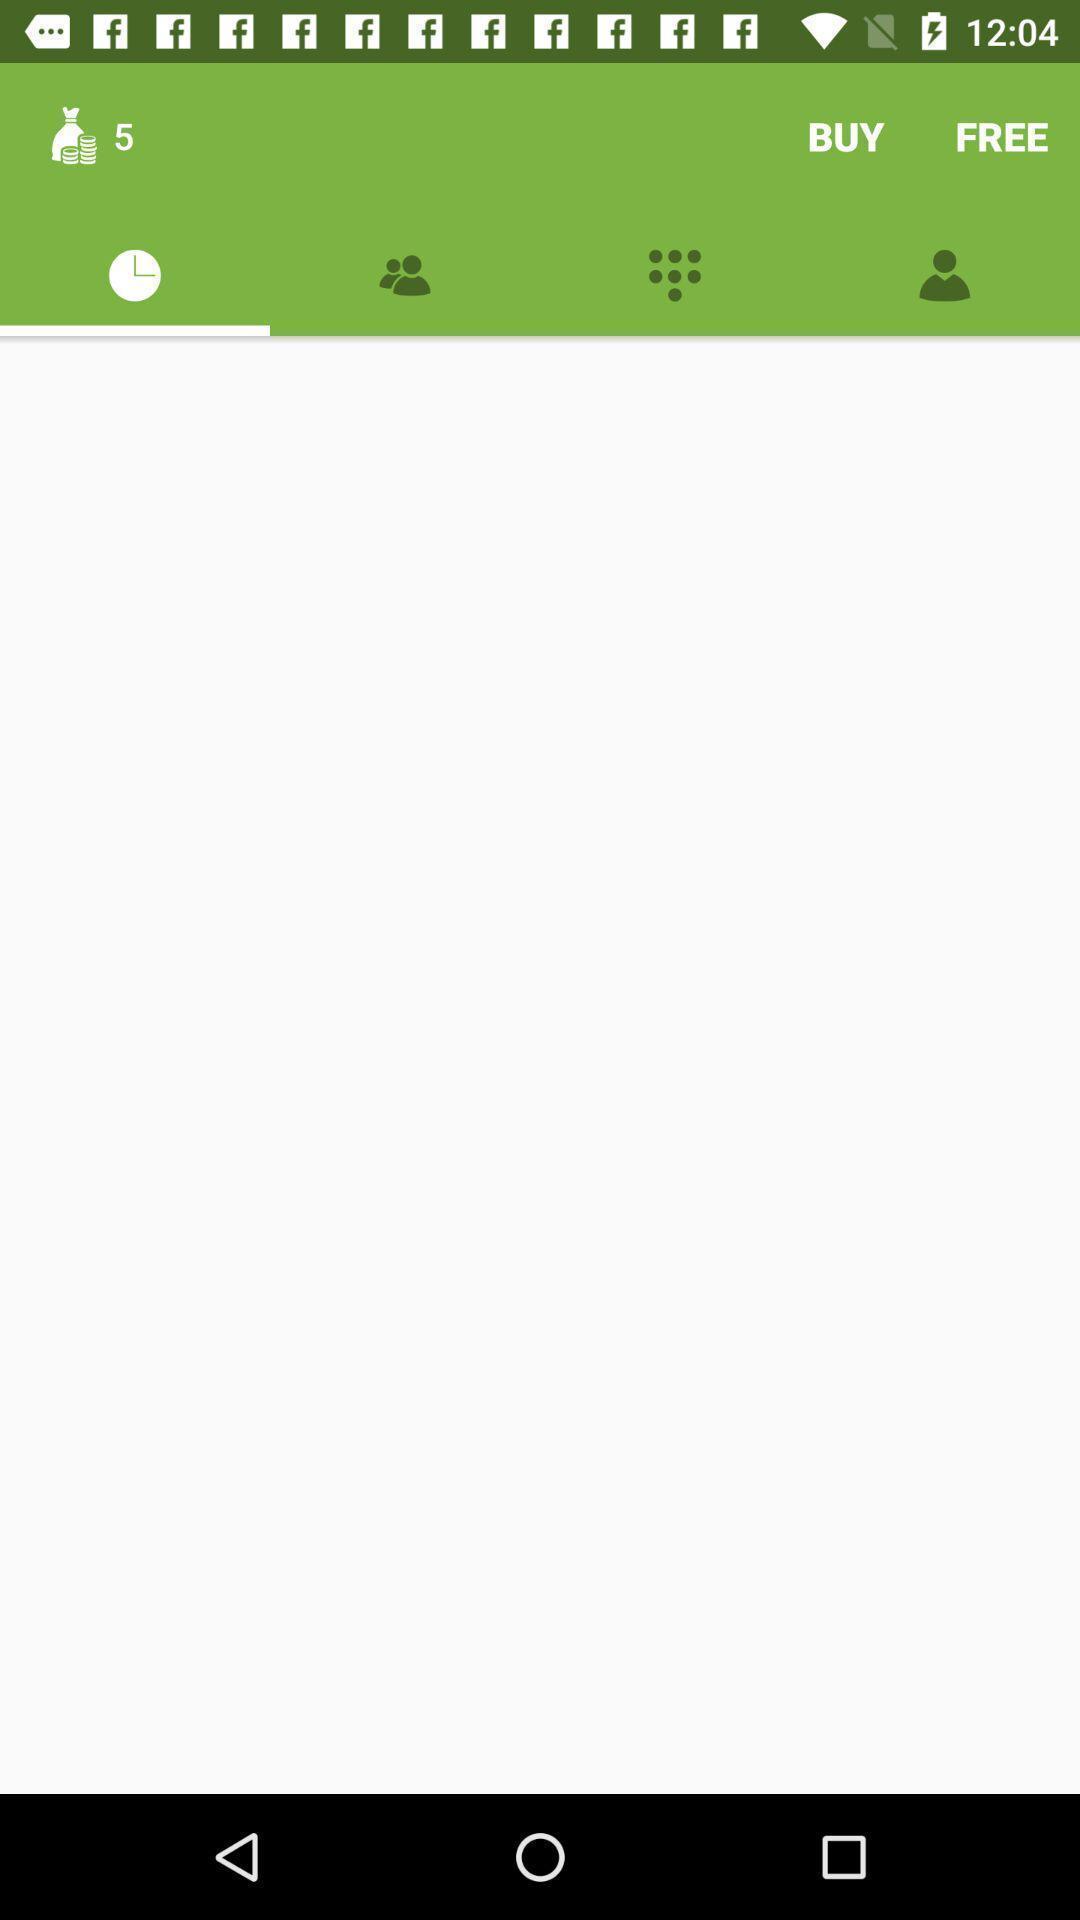Please provide a description for this image. Page with no content. 